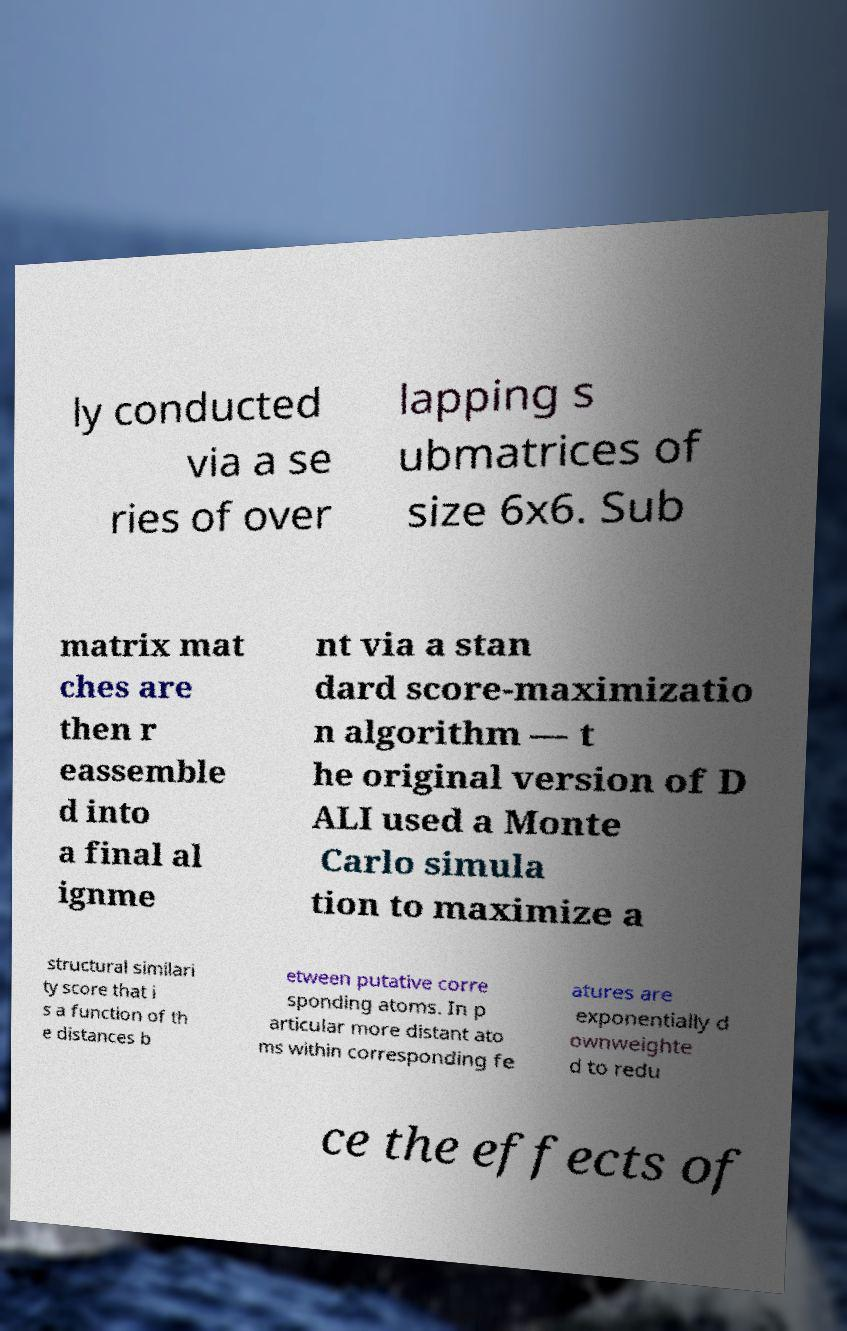Can you read and provide the text displayed in the image?This photo seems to have some interesting text. Can you extract and type it out for me? ly conducted via a se ries of over lapping s ubmatrices of size 6x6. Sub matrix mat ches are then r eassemble d into a final al ignme nt via a stan dard score-maximizatio n algorithm — t he original version of D ALI used a Monte Carlo simula tion to maximize a structural similari ty score that i s a function of th e distances b etween putative corre sponding atoms. In p articular more distant ato ms within corresponding fe atures are exponentially d ownweighte d to redu ce the effects of 